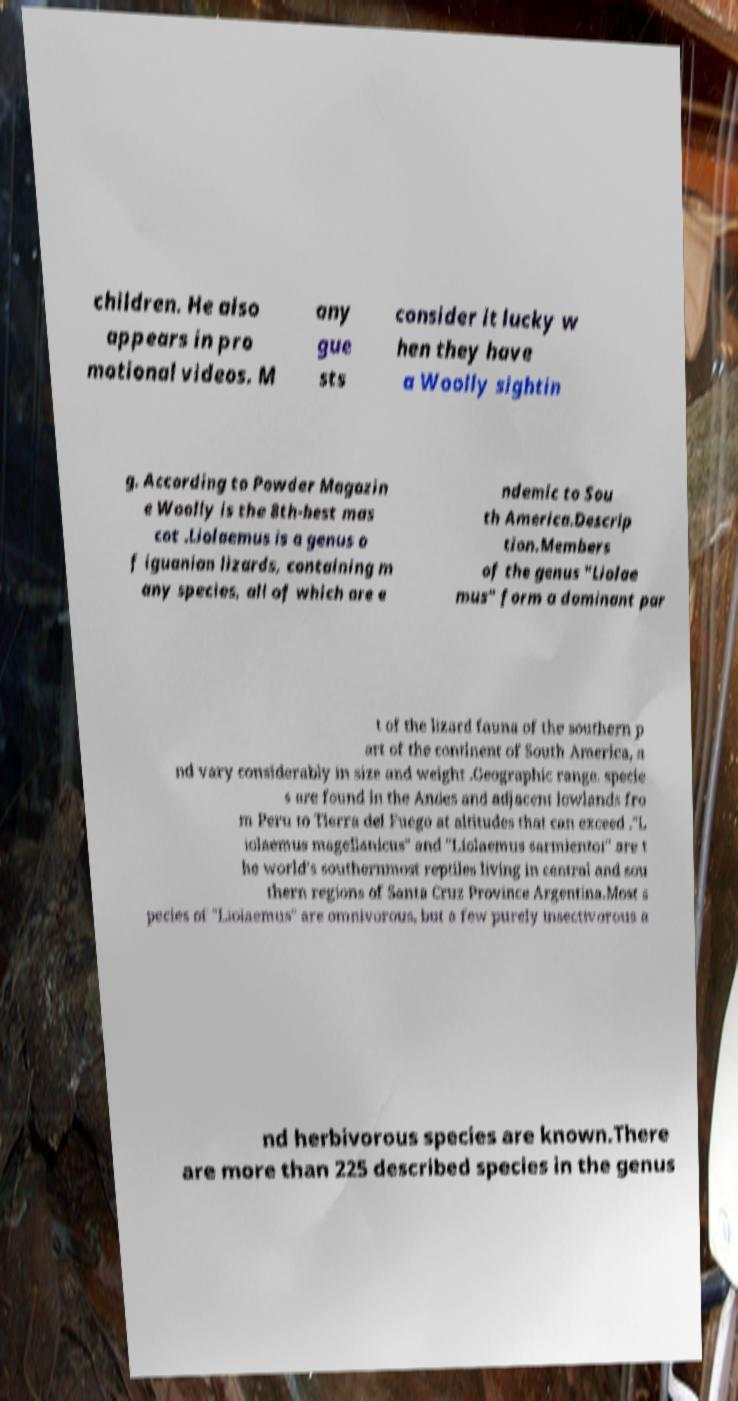Can you read and provide the text displayed in the image?This photo seems to have some interesting text. Can you extract and type it out for me? children. He also appears in pro motional videos. M any gue sts consider it lucky w hen they have a Woolly sightin g. According to Powder Magazin e Woolly is the 8th-best mas cot .Liolaemus is a genus o f iguanian lizards, containing m any species, all of which are e ndemic to Sou th America.Descrip tion.Members of the genus "Liolae mus" form a dominant par t of the lizard fauna of the southern p art of the continent of South America, a nd vary considerably in size and weight .Geographic range. specie s are found in the Andes and adjacent lowlands fro m Peru to Tierra del Fuego at altitudes that can exceed ."L iolaemus magellanicus" and "Liolaemus sarmientoi" are t he world's southernmost reptiles living in central and sou thern regions of Santa Cruz Province Argentina.Most s pecies of "Liolaemus" are omnivorous, but a few purely insectivorous a nd herbivorous species are known.There are more than 225 described species in the genus 